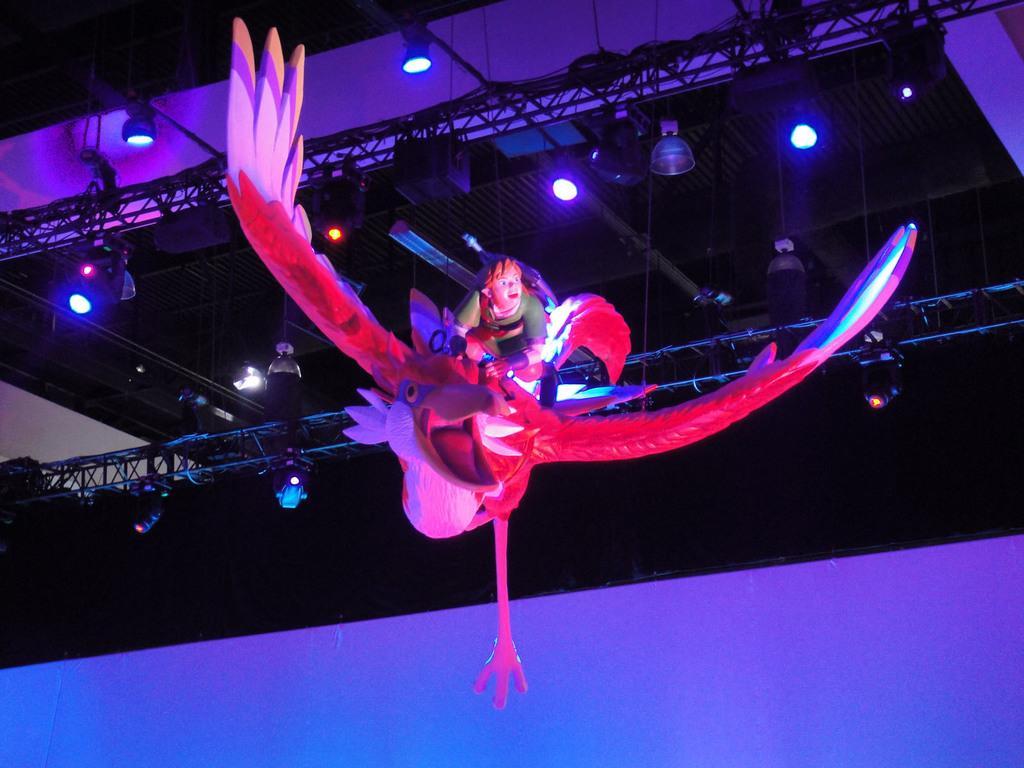How would you summarize this image in a sentence or two? In this image we can see an object which looks like a statue which represents a person sitting on bird and in the background, we can see stage lighting attached to the poles. 